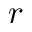<formula> <loc_0><loc_0><loc_500><loc_500>r</formula> 